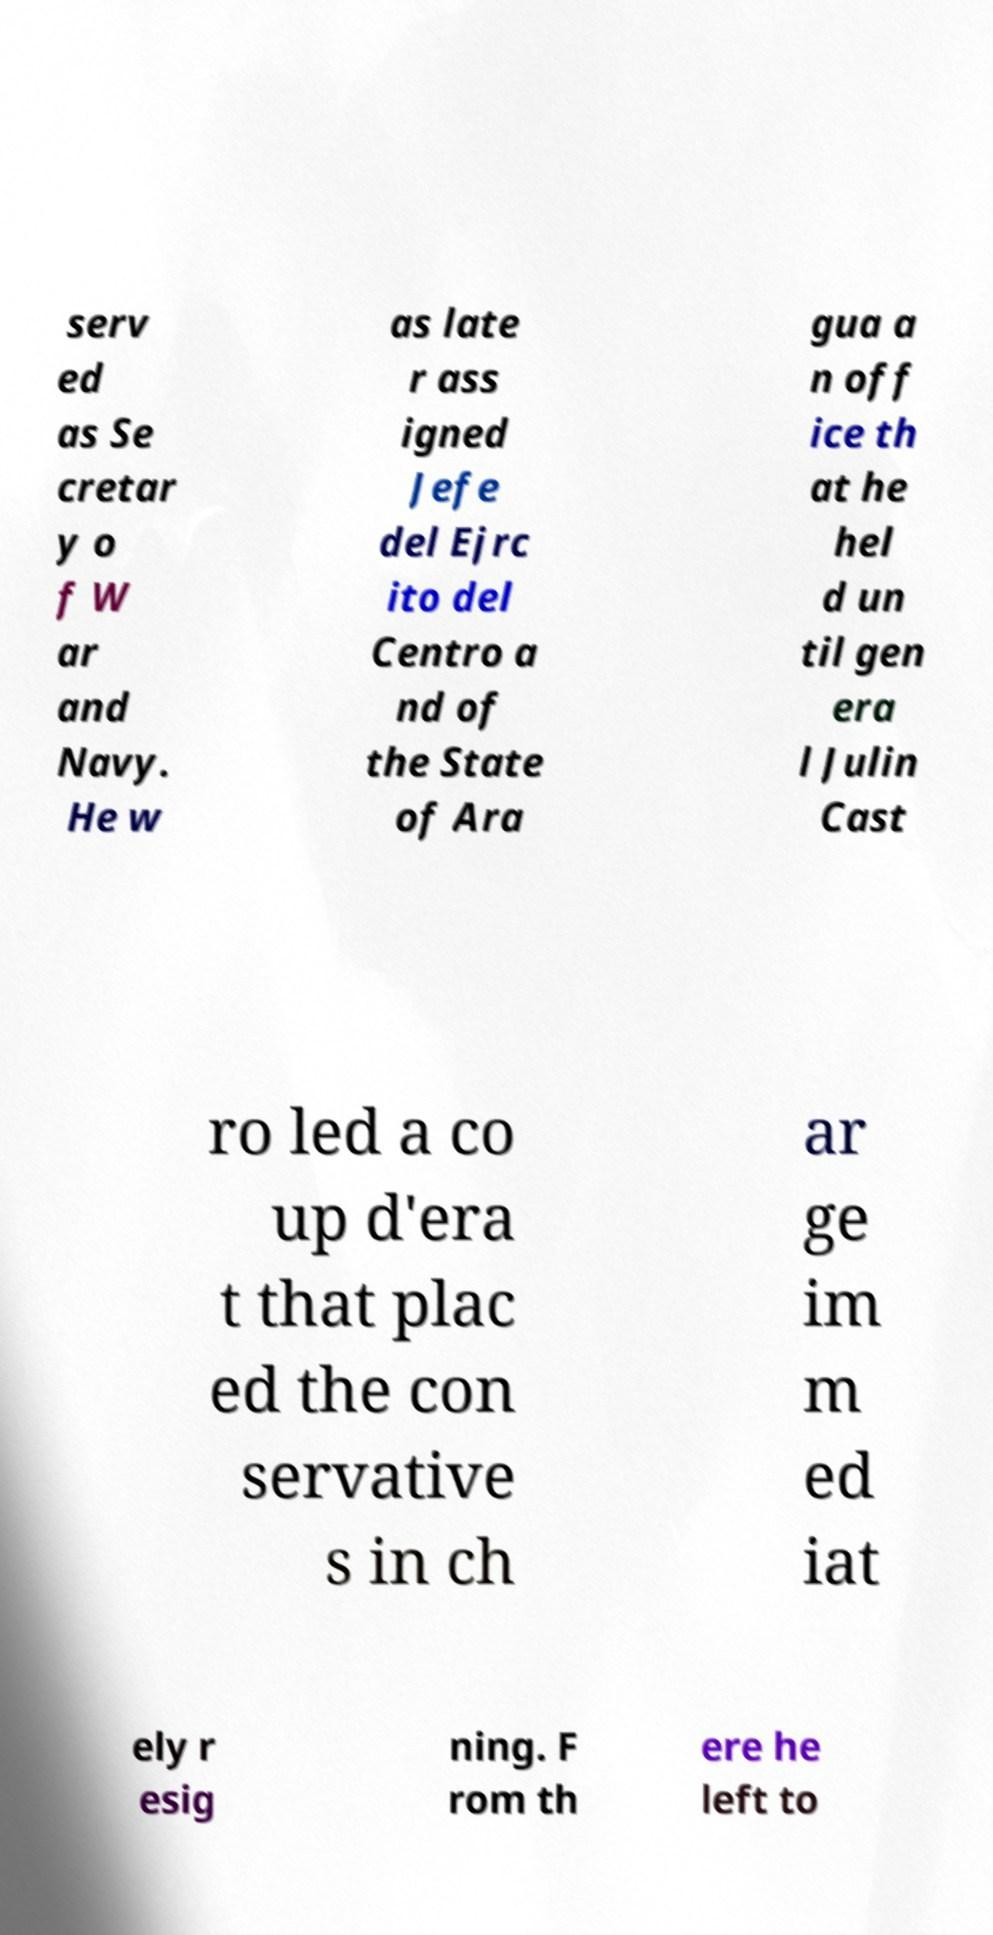I need the written content from this picture converted into text. Can you do that? serv ed as Se cretar y o f W ar and Navy. He w as late r ass igned Jefe del Ejrc ito del Centro a nd of the State of Ara gua a n off ice th at he hel d un til gen era l Julin Cast ro led a co up d'era t that plac ed the con servative s in ch ar ge im m ed iat ely r esig ning. F rom th ere he left to 